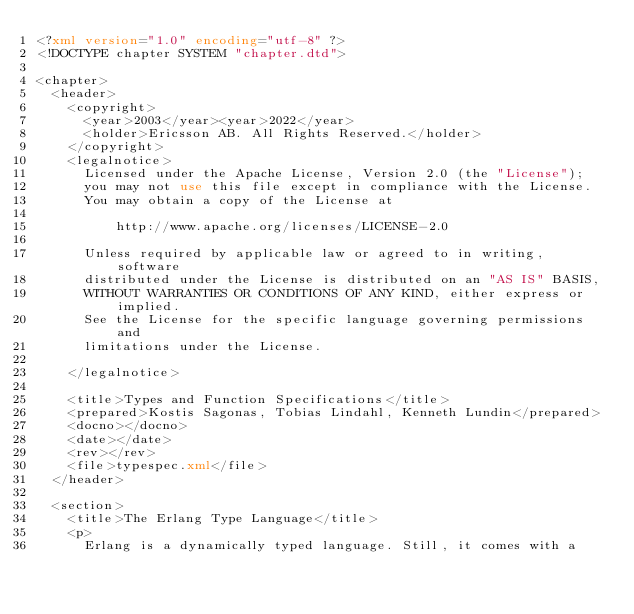<code> <loc_0><loc_0><loc_500><loc_500><_XML_><?xml version="1.0" encoding="utf-8" ?>
<!DOCTYPE chapter SYSTEM "chapter.dtd">

<chapter>
  <header>
    <copyright>
      <year>2003</year><year>2022</year>
      <holder>Ericsson AB. All Rights Reserved.</holder>
    </copyright>
    <legalnotice>
      Licensed under the Apache License, Version 2.0 (the "License");
      you may not use this file except in compliance with the License.
      You may obtain a copy of the License at

          http://www.apache.org/licenses/LICENSE-2.0

      Unless required by applicable law or agreed to in writing, software
      distributed under the License is distributed on an "AS IS" BASIS,
      WITHOUT WARRANTIES OR CONDITIONS OF ANY KIND, either express or implied.
      See the License for the specific language governing permissions and
      limitations under the License.

    </legalnotice>

    <title>Types and Function Specifications</title>
    <prepared>Kostis Sagonas, Tobias Lindahl, Kenneth Lundin</prepared>
    <docno></docno>
    <date></date>
    <rev></rev>
    <file>typespec.xml</file>
  </header>

  <section>
    <title>The Erlang Type Language</title>
    <p>
      Erlang is a dynamically typed language. Still, it comes with a</code> 